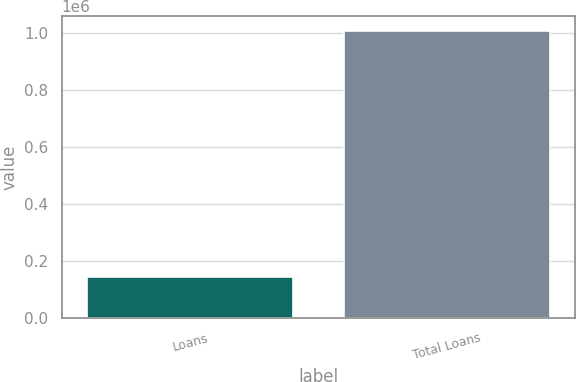Convert chart to OTSL. <chart><loc_0><loc_0><loc_500><loc_500><bar_chart><fcel>Loans<fcel>Total Loans<nl><fcel>144254<fcel>1.00619e+06<nl></chart> 